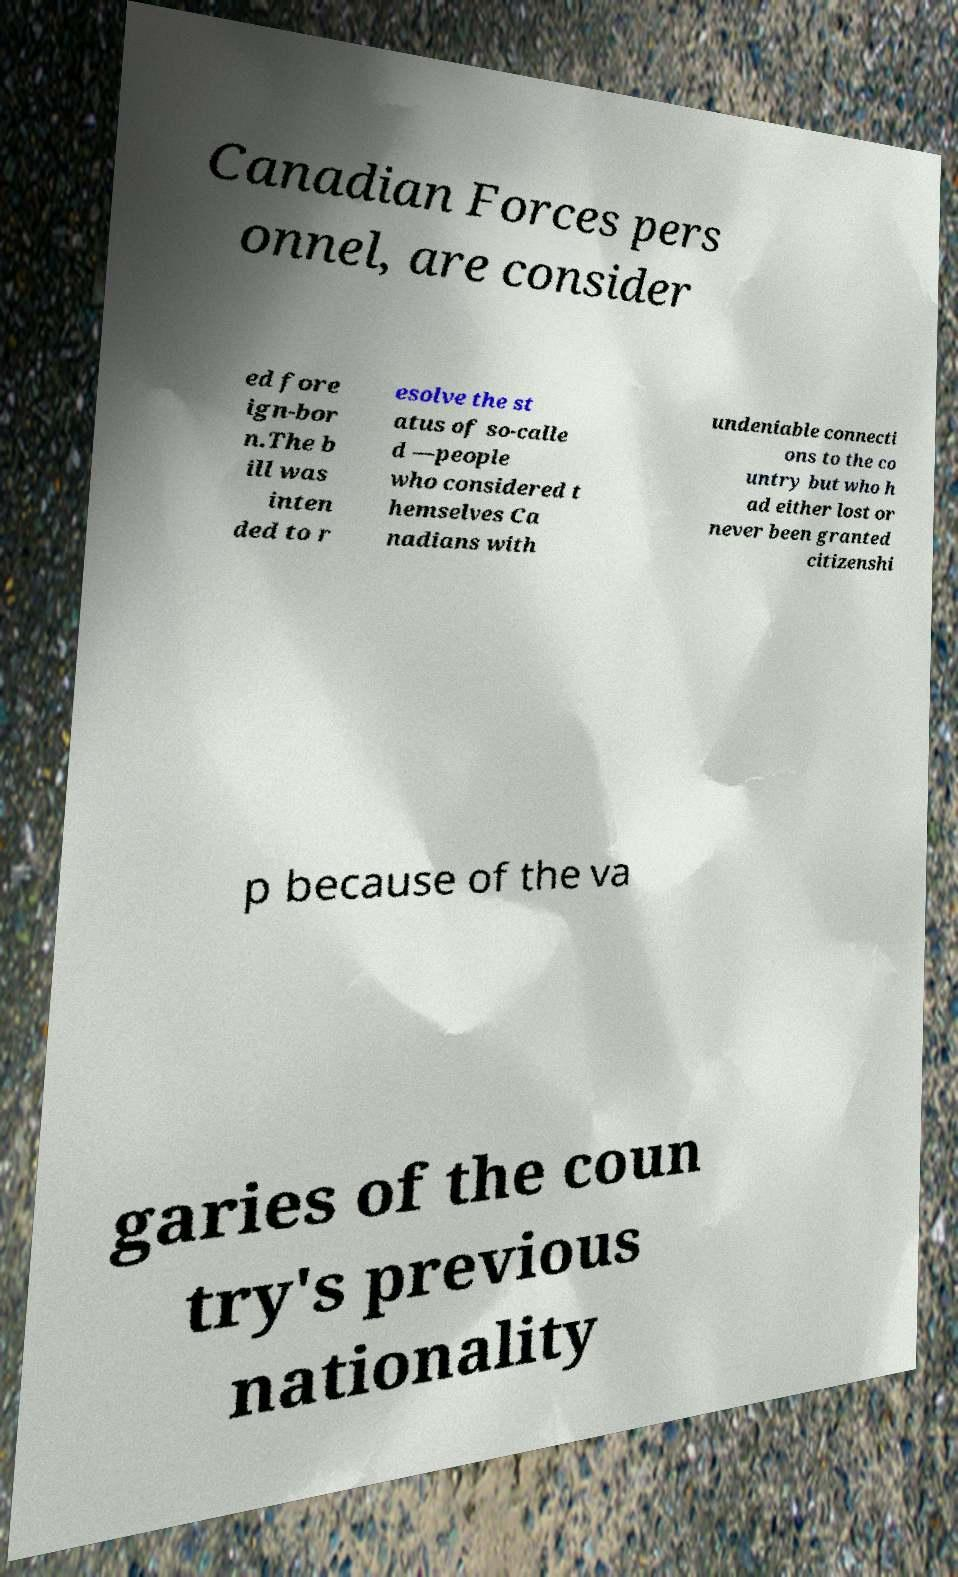Please identify and transcribe the text found in this image. Canadian Forces pers onnel, are consider ed fore ign-bor n.The b ill was inten ded to r esolve the st atus of so-calle d —people who considered t hemselves Ca nadians with undeniable connecti ons to the co untry but who h ad either lost or never been granted citizenshi p because of the va garies of the coun try's previous nationality 